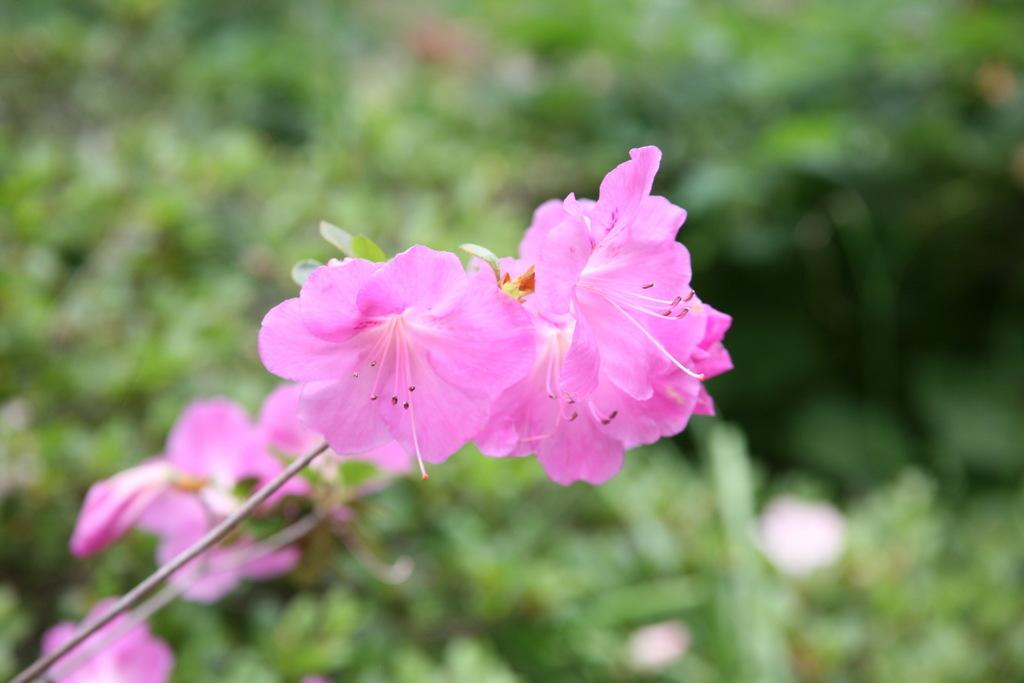What can be seen in the foreground of the picture? There are flowers in the foreground of the picture. How would you describe the background of the image? The background of the image is blurred. What types of vegetation are present in the background of the image? There are plants and flowers in the background of the image. How many rays of sunlight can be seen shining through the flowers in the image? There is no mention of sunlight or rays in the image, so it is not possible to determine how many rays are present. 